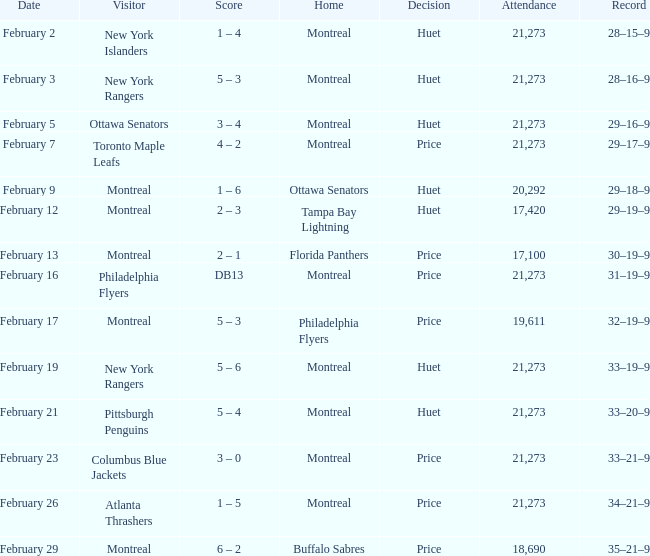Which team was the opponent when the canadiens had a 30-19-9 record during a game? Montreal. 